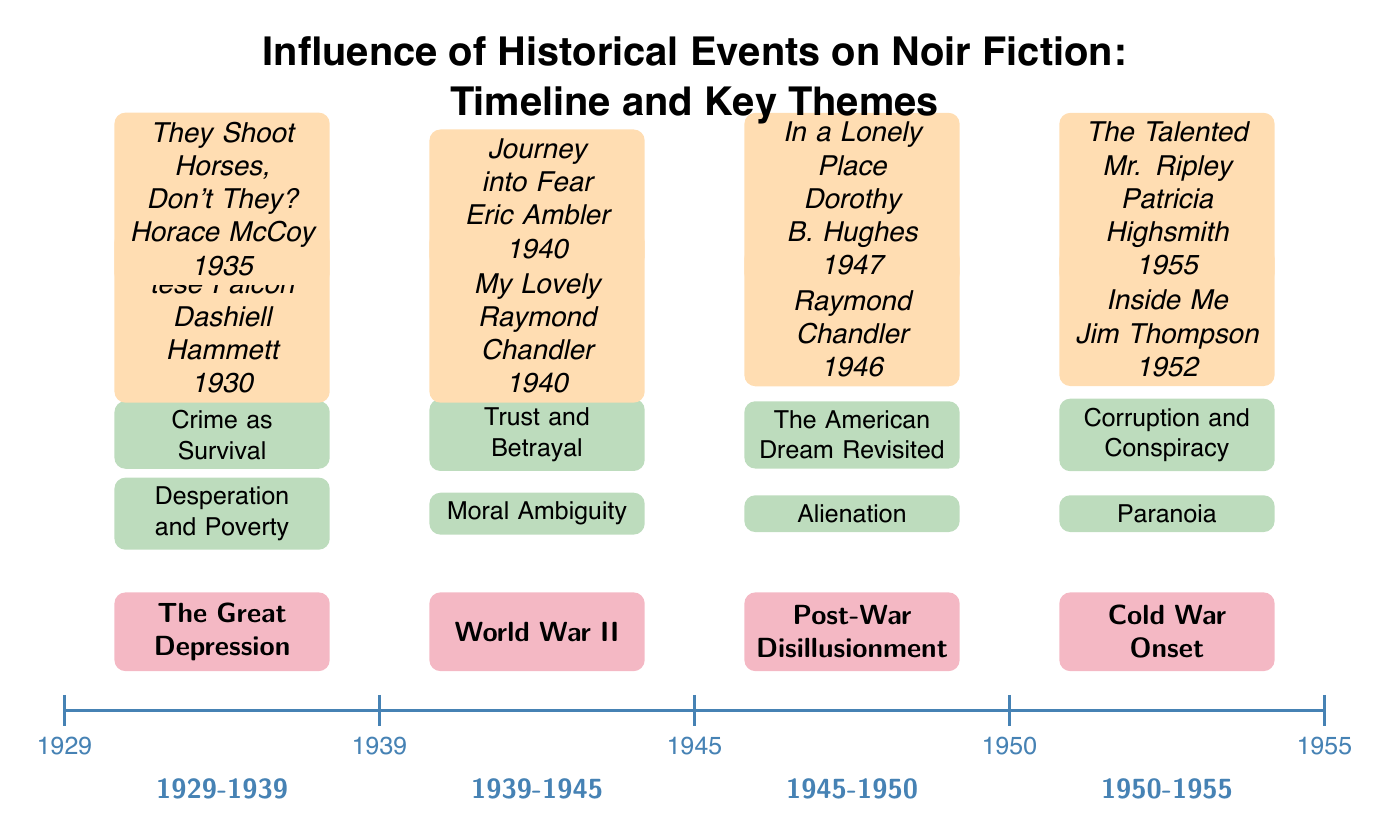What historical event is associated with the timeline year 1945? The diagram specifies that the year 1945 corresponds to the event "Post-War Disillusionment." This is identified as it falls directly under the year marker in the timeline.
Answer: Post-War Disillusionment Which theme corresponds with the historical event "The Great Depression"? The diagram indicates that the themes related to "The Great Depression" are "Desperation and Poverty" and "Crime as Survival." Both themes are positioned above this event in the diagram.
Answer: Desperation and Poverty; Crime as Survival How many key works of literature represent the "Cold War Onset" period? By analyzing the diagram, there are two works listed under the "Cold War Onset" event: "The Killer Inside Me" by Jim Thompson and "The Talented Mr. Ripley" by Patricia Highsmith. Therefore, the count is deduced directly from the works associated with this period in the diagram.
Answer: 2 What is the theme associated with the novel "Farewell, My Lovely"? The diagram shows that the novel "Farewell, My Lovely" falls under the "World War II" event, with the themes associated with it being "Moral Ambiguity" and "Trust and Betrayal." Thus, the answer refers back to the themes linked to this specific work.
Answer: Moral Ambiguity; Trust and Betrayal Which author wrote a key work during the "Post-War Disillusionment" period? The diagram lists two works under "Post-War Disillusionment": "The Big Sleep" by Raymond Chandler and "In a Lonely Place" by Dorothy B. Hughes. Therefore, any author from these two works can be the answer. The explanation indicates Raymond Chandler wrote one of those key works.
Answer: Raymond Chandler What period is represented between the years 1939 and 1945? The timeline in the diagram specifies that the period from 1939 to 1945 is marked as "1939-1945," which corresponds to the historical event "World War II." This is evident from observing the timeframe label under the timeline section.
Answer: 1939-1945 Identify one theme that is associated with the "Cold War Onset." The diagram lists "Paranoia" and "Corruption and Conspiracy" as the themes linked to the "Cold War Onset," which shows the sociopolitical climate at that time reflected in literature. Thus, either theme qualifies as the answer.
Answer: Paranoia; Corruption and Conspiracy What is the significance of the timeline in relation to the sociopolitical themes? The diagram illustrates a sequential relationship between historical events and the themes present in notable Noir fiction works, emphasizing how literature reflects the sociopolitical context of its time. This exploratory analysis serves a dual function of mapping time with thematic relevance.
Answer: Sequential relationship 